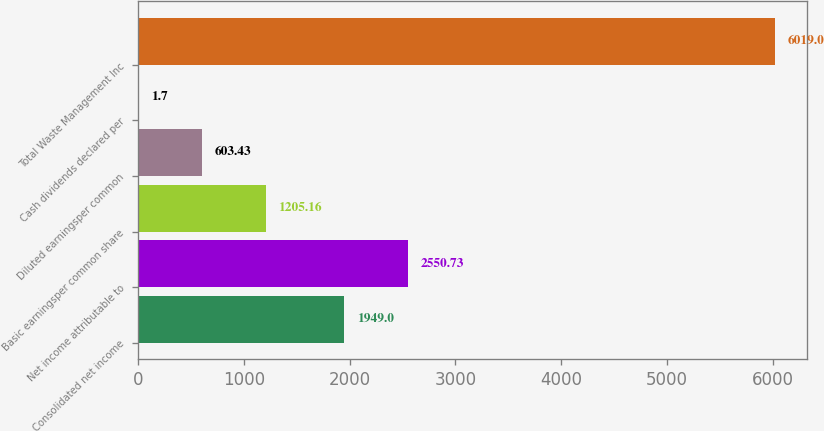Convert chart to OTSL. <chart><loc_0><loc_0><loc_500><loc_500><bar_chart><fcel>Consolidated net income<fcel>Net income attributable to<fcel>Basic earningsper common share<fcel>Diluted earningsper common<fcel>Cash dividends declared per<fcel>Total Waste Management Inc<nl><fcel>1949<fcel>2550.73<fcel>1205.16<fcel>603.43<fcel>1.7<fcel>6019<nl></chart> 